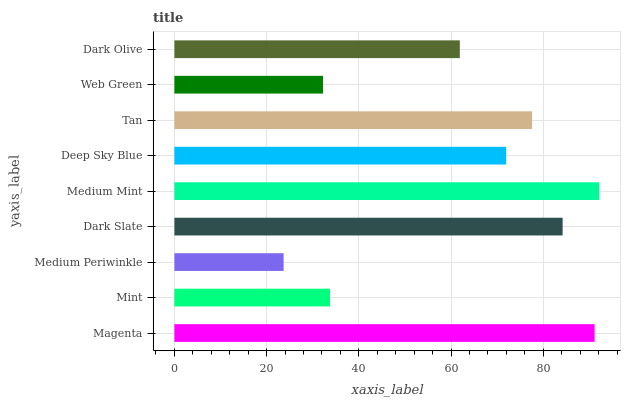Is Medium Periwinkle the minimum?
Answer yes or no. Yes. Is Medium Mint the maximum?
Answer yes or no. Yes. Is Mint the minimum?
Answer yes or no. No. Is Mint the maximum?
Answer yes or no. No. Is Magenta greater than Mint?
Answer yes or no. Yes. Is Mint less than Magenta?
Answer yes or no. Yes. Is Mint greater than Magenta?
Answer yes or no. No. Is Magenta less than Mint?
Answer yes or no. No. Is Deep Sky Blue the high median?
Answer yes or no. Yes. Is Deep Sky Blue the low median?
Answer yes or no. Yes. Is Dark Slate the high median?
Answer yes or no. No. Is Dark Slate the low median?
Answer yes or no. No. 